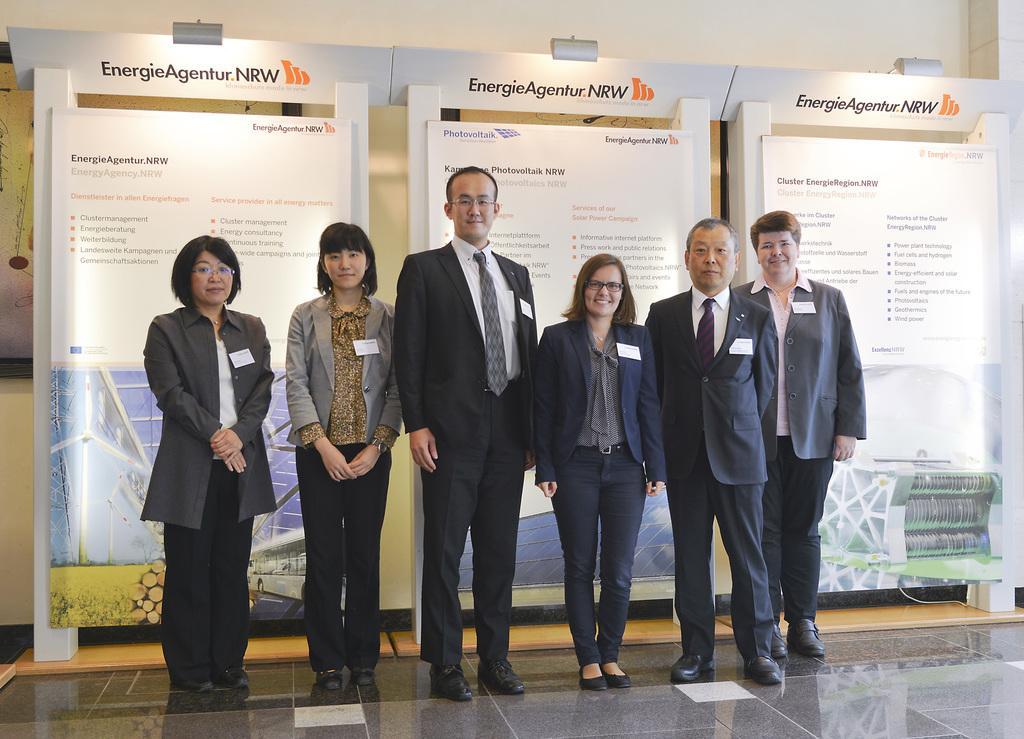How would you summarize this image in a sentence or two? Here I can see few people are standing on the floor, smiling and giving pose for the picture. At the back of these people there are three boards on which I can see the text. In the background there are few frames attached to the wall. 